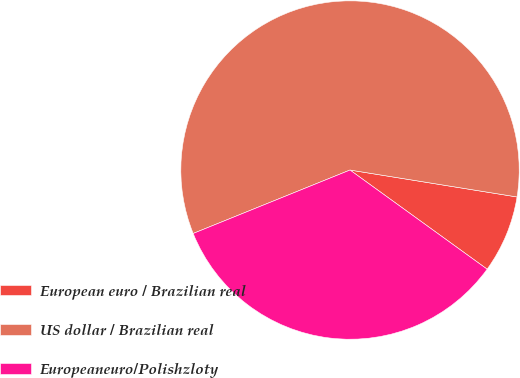Convert chart. <chart><loc_0><loc_0><loc_500><loc_500><pie_chart><fcel>European euro / Brazilian real<fcel>US dollar / Brazilian real<fcel>Europeaneuro/Polishzloty<nl><fcel>7.42%<fcel>58.66%<fcel>33.92%<nl></chart> 